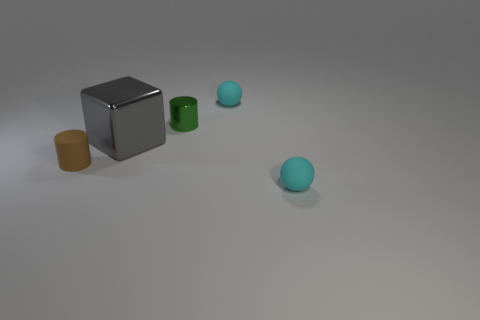Is there any other thing that has the same size as the block?
Your answer should be very brief. No. How many other objects are there of the same material as the green cylinder?
Ensure brevity in your answer.  1. There is a ball that is in front of the big gray object; is it the same size as the gray shiny block behind the brown matte cylinder?
Keep it short and to the point. No. There is a thing that is made of the same material as the gray cube; what color is it?
Make the answer very short. Green. Are the cyan object in front of the tiny green metallic cylinder and the cyan ball that is behind the small shiny object made of the same material?
Provide a succinct answer. Yes. Is there a brown rubber object of the same size as the green shiny cylinder?
Your response must be concise. Yes. What is the size of the cyan rubber sphere that is in front of the cyan rubber sphere that is behind the green metallic thing?
Your answer should be compact. Small. What number of cubes have the same color as the big metal thing?
Provide a short and direct response. 0. There is a gray shiny object right of the small matte object left of the green metal cylinder; what is its shape?
Offer a terse response. Cube. How many tiny cyan things have the same material as the big gray thing?
Your answer should be very brief. 0. 